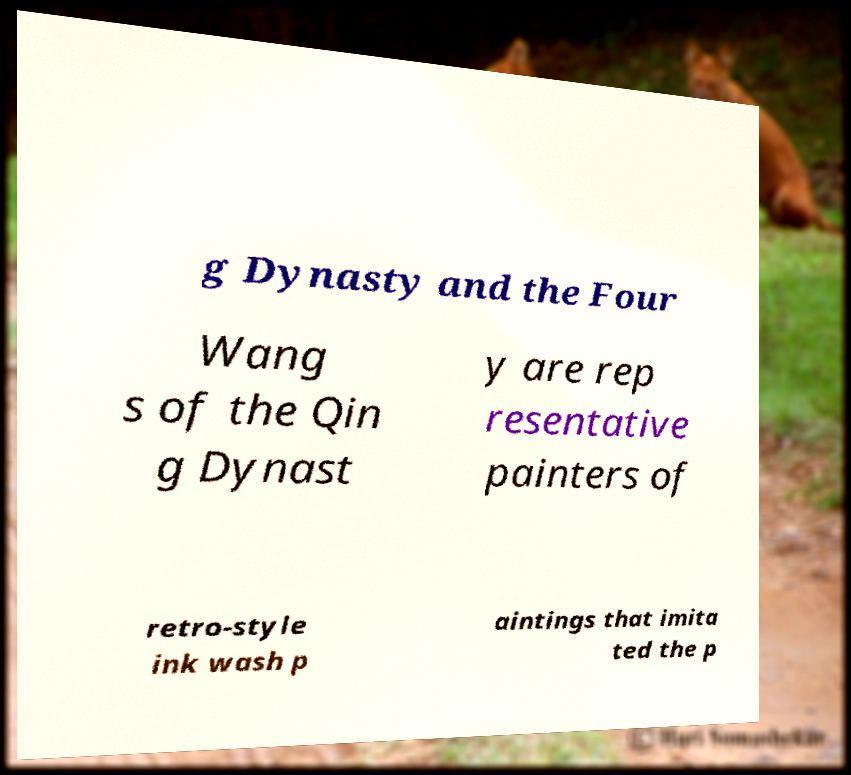I need the written content from this picture converted into text. Can you do that? g Dynasty and the Four Wang s of the Qin g Dynast y are rep resentative painters of retro-style ink wash p aintings that imita ted the p 